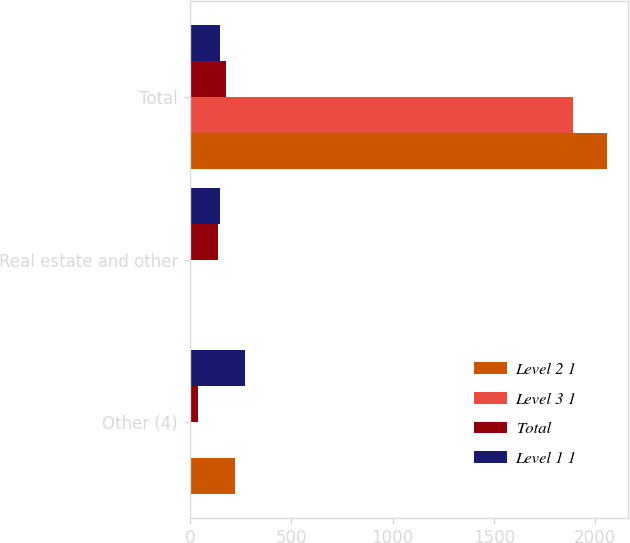Convert chart. <chart><loc_0><loc_0><loc_500><loc_500><stacked_bar_chart><ecel><fcel>Other (4)<fcel>Real estate and other<fcel>Total<nl><fcel>Level 2 1<fcel>225<fcel>1<fcel>2060<nl><fcel>Level 3 1<fcel>7<fcel>7<fcel>1889<nl><fcel>Total<fcel>39<fcel>139<fcel>178<nl><fcel>Level 1 1<fcel>271<fcel>147<fcel>147<nl></chart> 